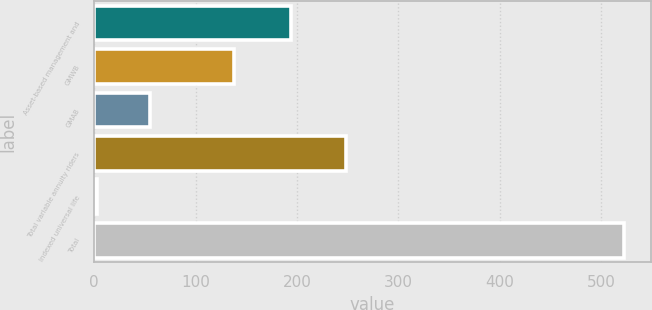<chart> <loc_0><loc_0><loc_500><loc_500><bar_chart><fcel>Asset-based management and<fcel>GMWB<fcel>GMAB<fcel>Total variable annuity riders<fcel>Indexed universal life<fcel>Total<nl><fcel>194<fcel>138<fcel>55<fcel>248<fcel>3<fcel>523<nl></chart> 